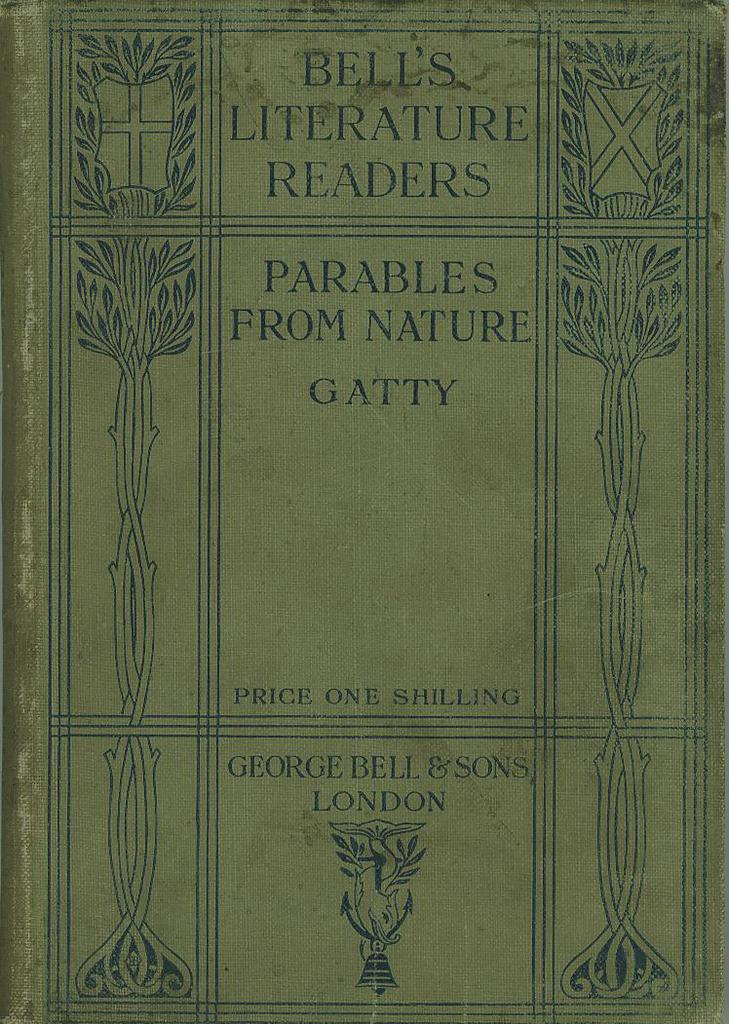<image>
Write a terse but informative summary of the picture. The front cover of the book Parables From Nature. 